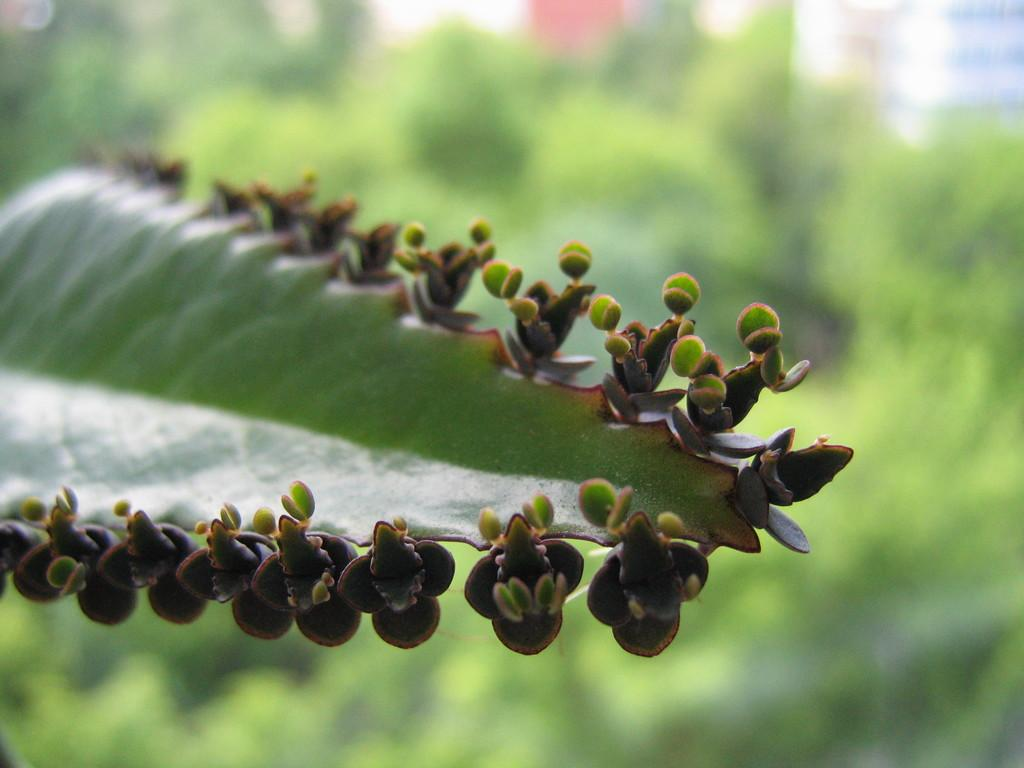What is the main subject of the image? The main subject of the image is a leaf. How close is the view of the leaf in the image? The image is a zoomed-in view of the leaf. What can be observed about the background in the image? The background of the leaf is blurred. What type of thrill can be seen on the leaf in the image? There is no thrill present on the leaf in the image; it is a "thrill" is not a relevant term to describe a leaf. 